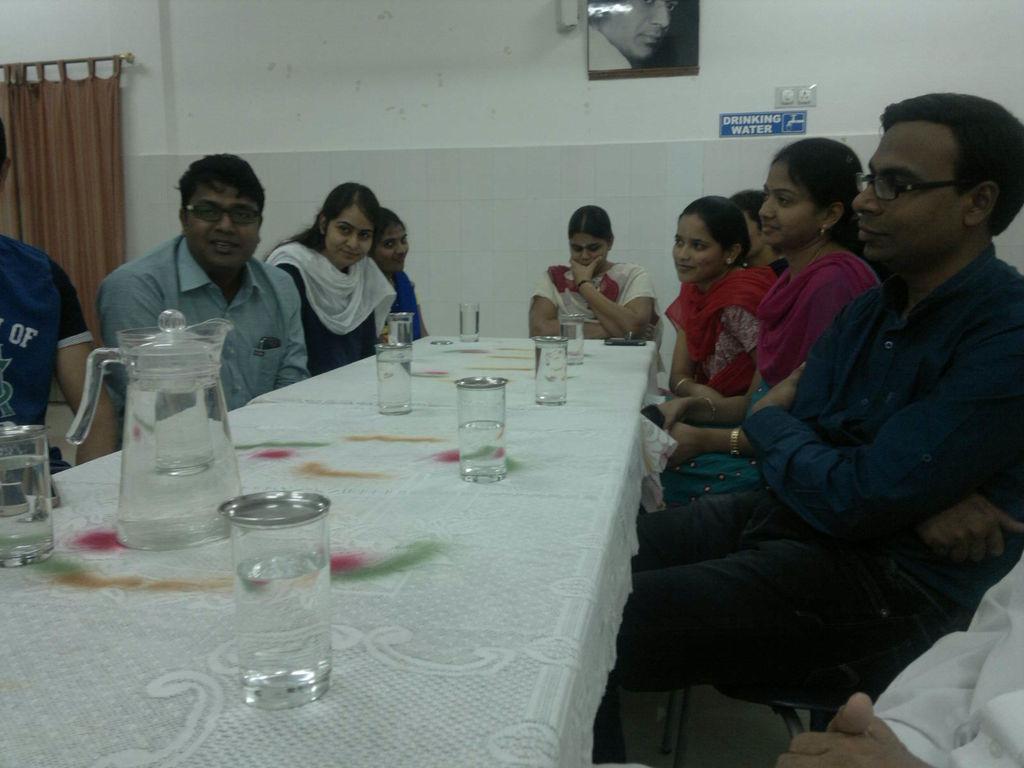Please provide a concise description of this image. It is a closed room where people are sitting on the chairs and in front of them there is a table and some water glasses and a jar present on it. Behind them there is a white colour wall and a curtain there is a signboard and a photo on the wall. In the picture there are six women and three men. 